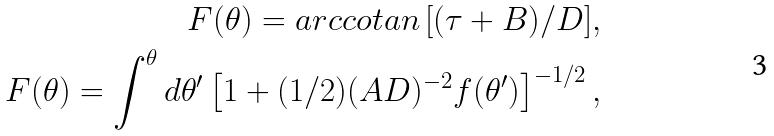Convert formula to latex. <formula><loc_0><loc_0><loc_500><loc_500>F ( \theta ) = a r c c o t a n \, [ ( \tau + B ) / D ] , \\ F ( \theta ) = \int ^ { \theta } d { \theta } ^ { \prime } \left [ 1 + ( 1 / 2 ) ( A D ) ^ { - 2 } f ( \theta ^ { \prime } ) \right ] ^ { - 1 / 2 } ,</formula> 